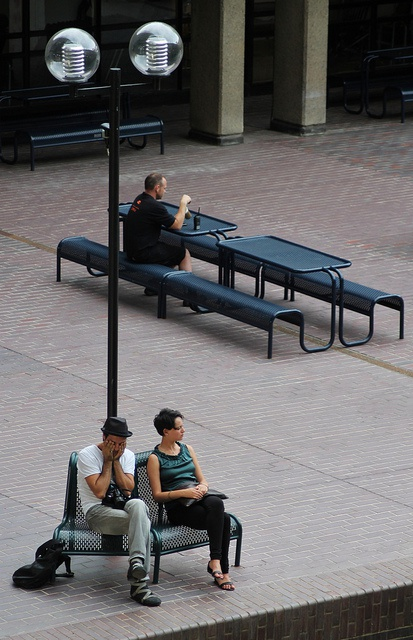Describe the objects in this image and their specific colors. I can see people in black, darkgray, gray, and maroon tones, people in black, darkgray, brown, and gray tones, bench in black, gray, and darkgray tones, dining table in black, gray, and darkgray tones, and bench in black, gray, blue, and darkblue tones in this image. 